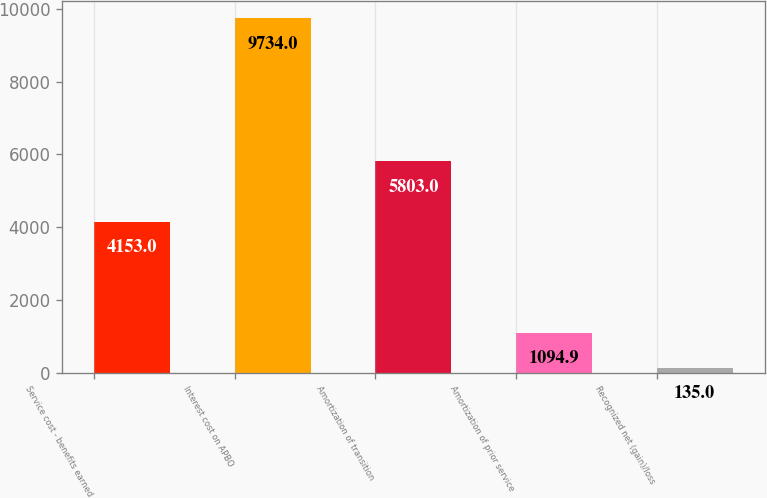<chart> <loc_0><loc_0><loc_500><loc_500><bar_chart><fcel>Service cost - benefits earned<fcel>Interest cost on APBO<fcel>Amortization of transition<fcel>Amortization of prior service<fcel>Recognized net (gain)/loss<nl><fcel>4153<fcel>9734<fcel>5803<fcel>1094.9<fcel>135<nl></chart> 